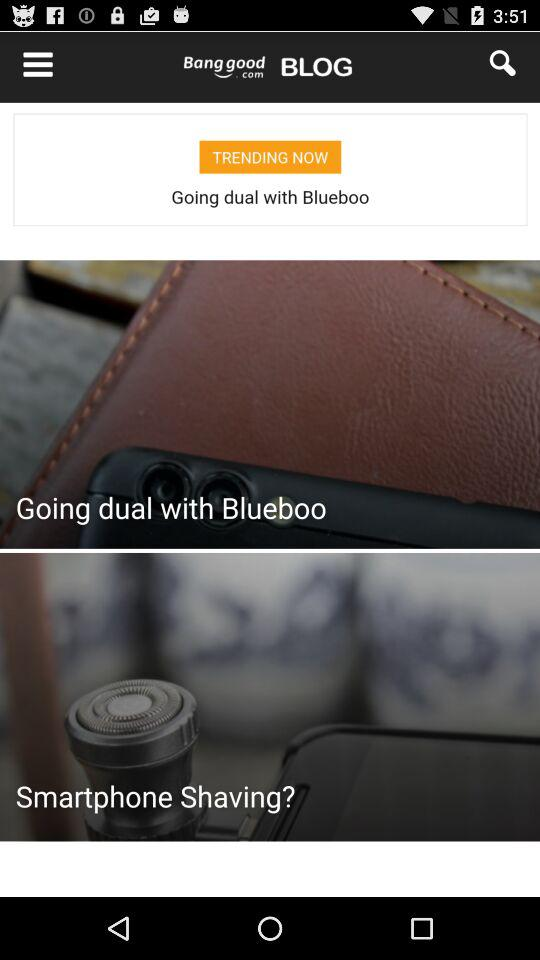What item is rated 5 stars? The item that is rated 5 stars is the "Bow Belt Solid Color Mesh Tulle Pleated High Waist Women Maxi Skirt". 